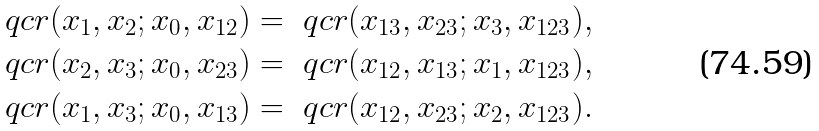<formula> <loc_0><loc_0><loc_500><loc_500>\ q c r ( x _ { 1 } , x _ { 2 } ; x _ { 0 } , x _ { 1 2 } ) & = \ q c r ( x _ { 1 3 } , x _ { 2 3 } ; x _ { 3 } , x _ { 1 2 3 } ) , \\ \ q c r ( x _ { 2 } , x _ { 3 } ; x _ { 0 } , x _ { 2 3 } ) & = \ q c r ( x _ { 1 2 } , x _ { 1 3 } ; x _ { 1 } , x _ { 1 2 3 } ) , \\ \ q c r ( x _ { 1 } , x _ { 3 } ; x _ { 0 } , x _ { 1 3 } ) & = \ q c r ( x _ { 1 2 } , x _ { 2 3 } ; x _ { 2 } , x _ { 1 2 3 } ) .</formula> 